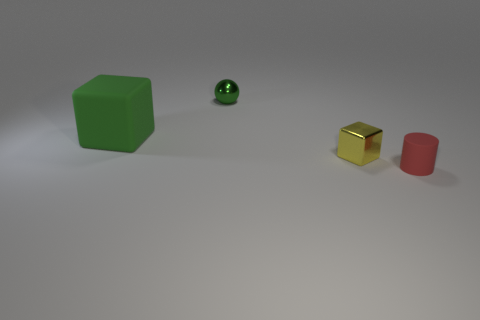Subtract 1 red cylinders. How many objects are left? 3 Subtract all spheres. How many objects are left? 3 Subtract 1 spheres. How many spheres are left? 0 Subtract all yellow blocks. Subtract all cyan balls. How many blocks are left? 1 Subtract all red cubes. How many purple cylinders are left? 0 Subtract all green things. Subtract all small metallic spheres. How many objects are left? 1 Add 3 small yellow things. How many small yellow things are left? 4 Add 2 cubes. How many cubes exist? 4 Add 3 small things. How many objects exist? 7 